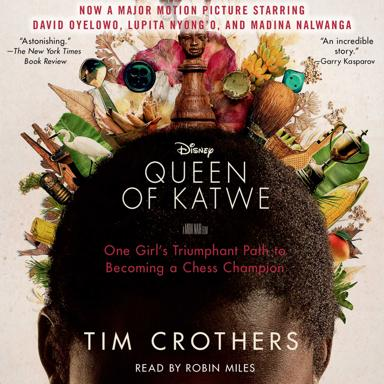How does the environment of Katwe influence the story told in the movie? The environment of Katwe, characterized by its harsh poverty and bustling community life, serves as both a backdrop and a catalyst in the movie. It presents the stark contrasts of hardships and the vibrant spirit of the community, influencing Phiona’s experiences and shaping her remarkable quest for a better life. 